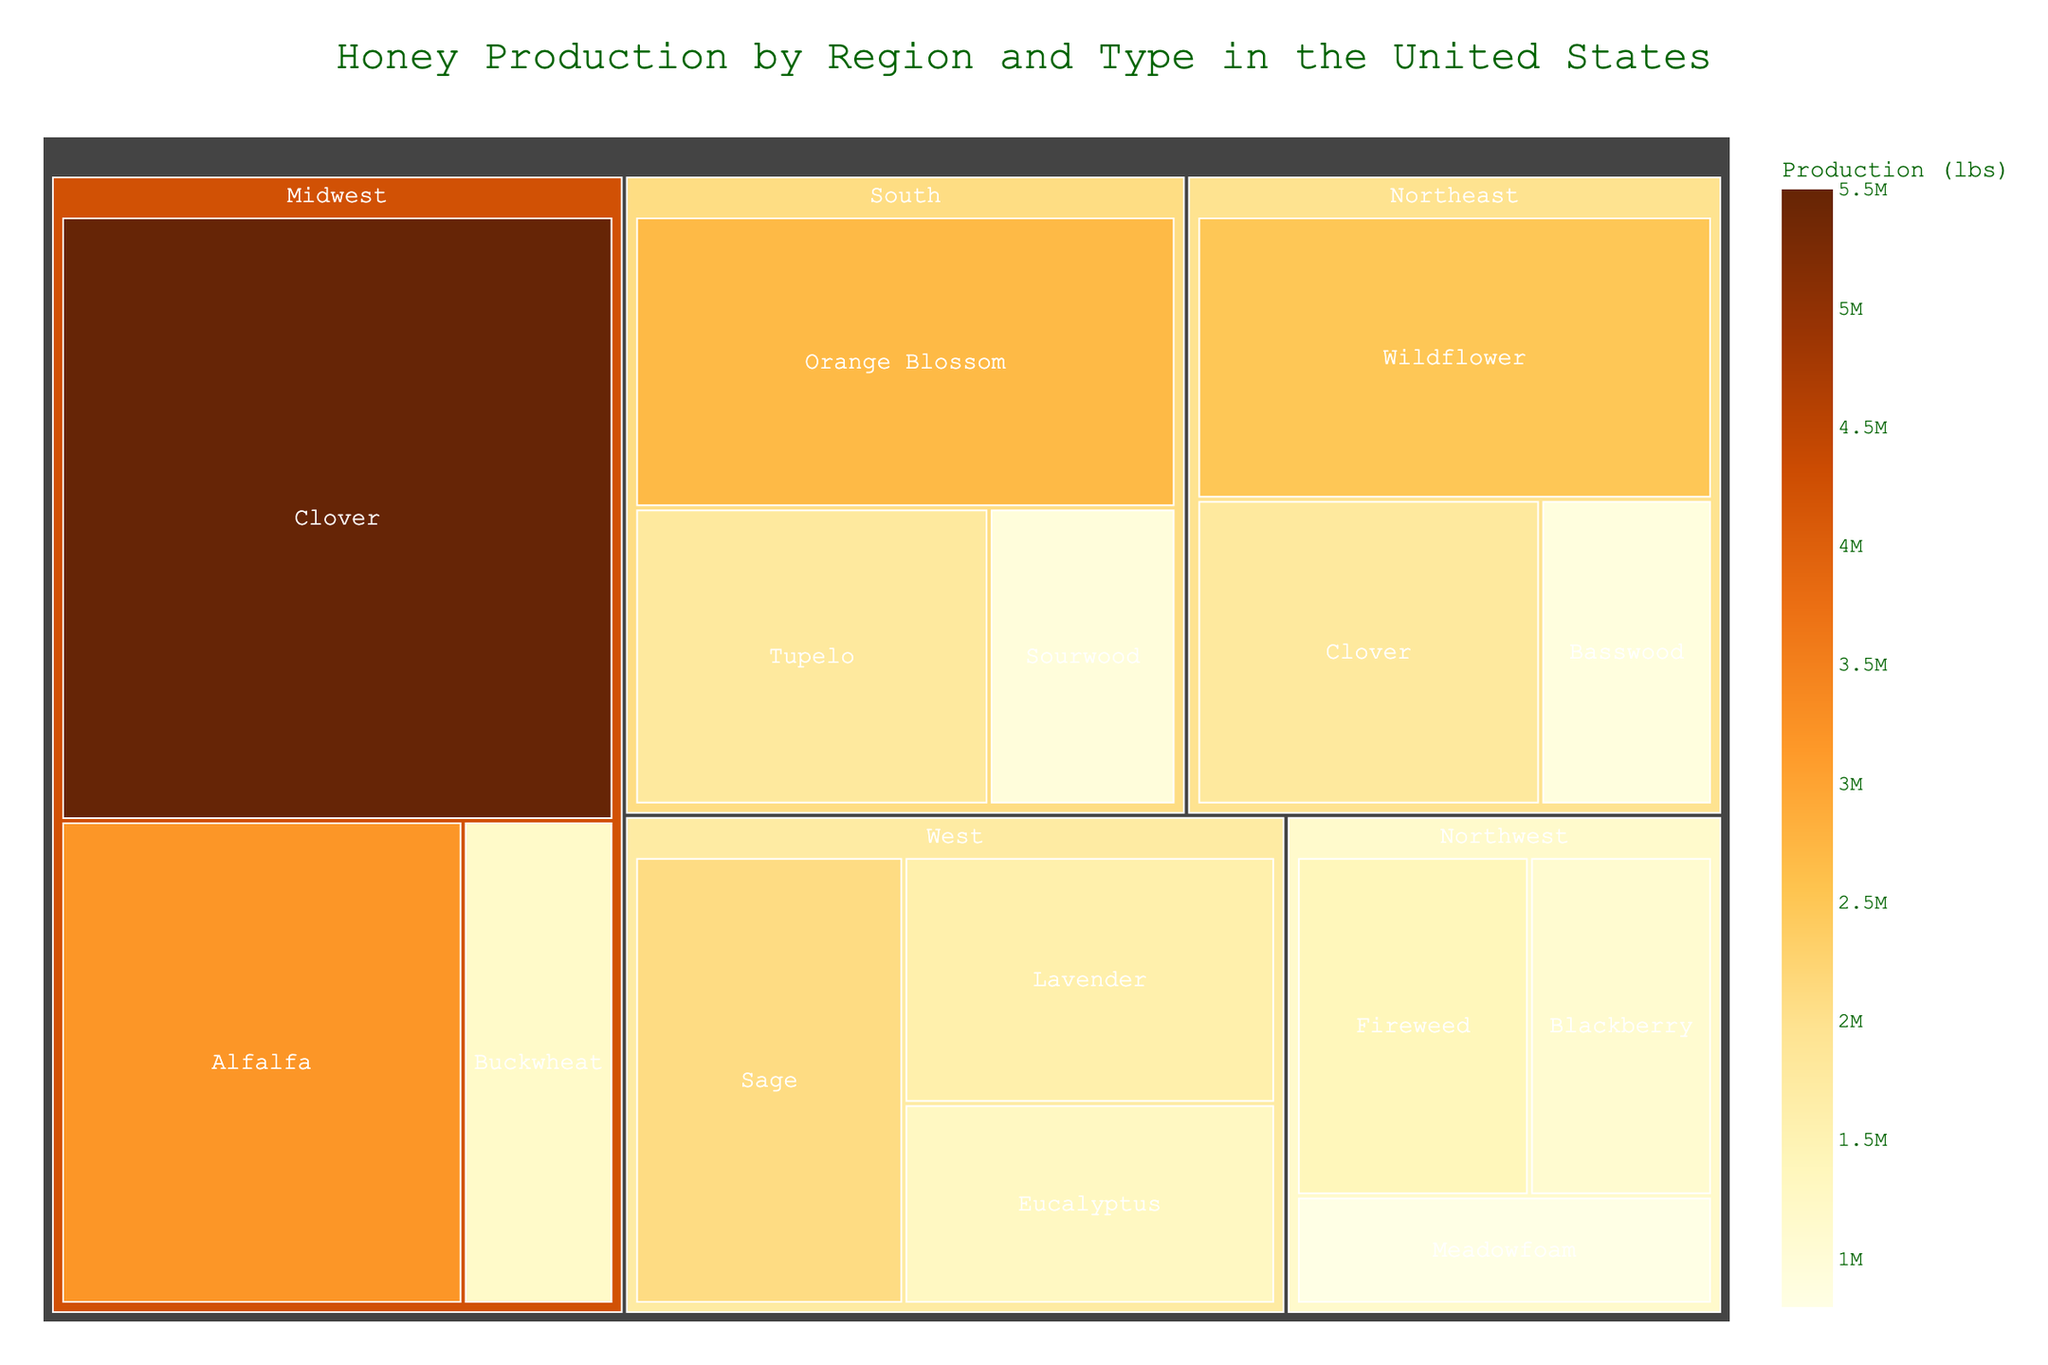What is the title of the treemap? The title is the highest level of text prominently displaying the main subject of the plot. Reading it directly gives the answer.
Answer: Honey Production by Region and Type in the United States Which region produces the most Clover honey? Look within the "Clover" category and compare the sections belonging to different regions in terms of area size. Identify which region's portion is the largest.
Answer: Midwest How much Wildflower honey is produced in the Northeast? Locate the Wildflower category under the Northeast section of the treemap and read its production value.
Answer: 2,500,000 lbs Which honey type has the smallest production in the Northwest? Search the Northwest section and compare the sizes of areas for each honey type. The smallest area represents the lowest production.
Answer: Meadowfoam What is the total production of honey in the South region? Sum the production values of all honey types in the South region: Tupelo (1,800,000 lbs), Orange Blossom (2,700,000 lbs), and Sourwood (950,000 lbs).
Answer: 5,450,000 lbs Which region produces more Eucalyptus honey, the West or the Northwest? Compare the Eucalyptus honey productions by locating and quantifying the respective production values under the West and Northwest sections.
Answer: West Rank the regions from highest to lowest total honey production. Sum the production values of all honey types within each region and then rank them accordingly. For example, add production values for both Northeast, Midwest, South, West, and Northwest.
Answer: Midwest > West > South > Northeast > Northwest Which region has the highest diversity of honey types, based on the figure? Count the number of different honey types listed under each region in the treemap. The region with the highest count has the most diversity.
Answer: South What is the difference in honey production between the highest-producing and lowest-producing types in the West? Identify the production values of the largest and smallest types in the West (Sage: 2,100,000 lbs and Eucalyptus: 1,300,000 lbs) and subtract the smaller value from the larger one.
Answer: 800,000 lbs Which regions produce Orange Blossom honey? Scan the treemap for sections labeled "Orange Blossom" and identify their respective regions.
Answer: South 